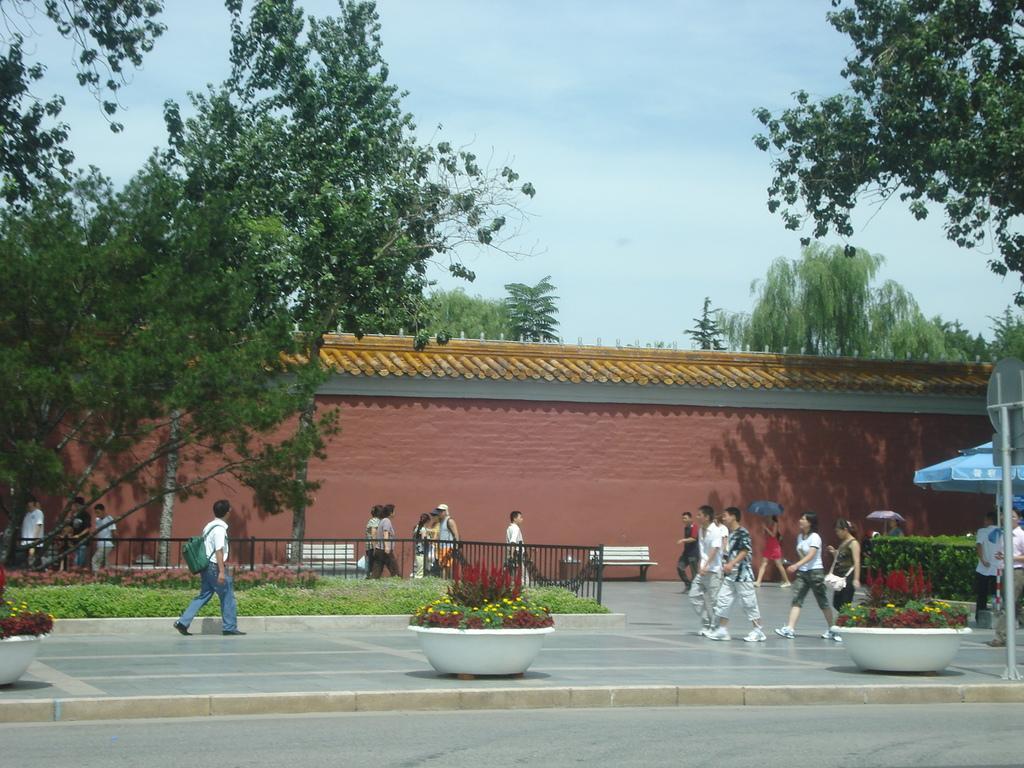Please provide a concise description of this image. In this image, we can see a wall, roof, trees, plants, pots, flowers, grills. Here we can see few people, benches. Few people are walking. On the right side of the image, we can see a pole with board and umbrella. Background there is a sky. At the bottom, there is a road and footpath. 